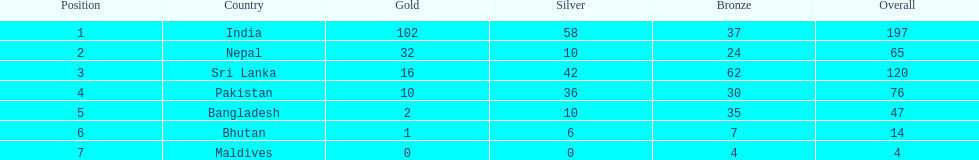What is the difference between the nation with the most medals and the nation with the least amount of medals? 193. 